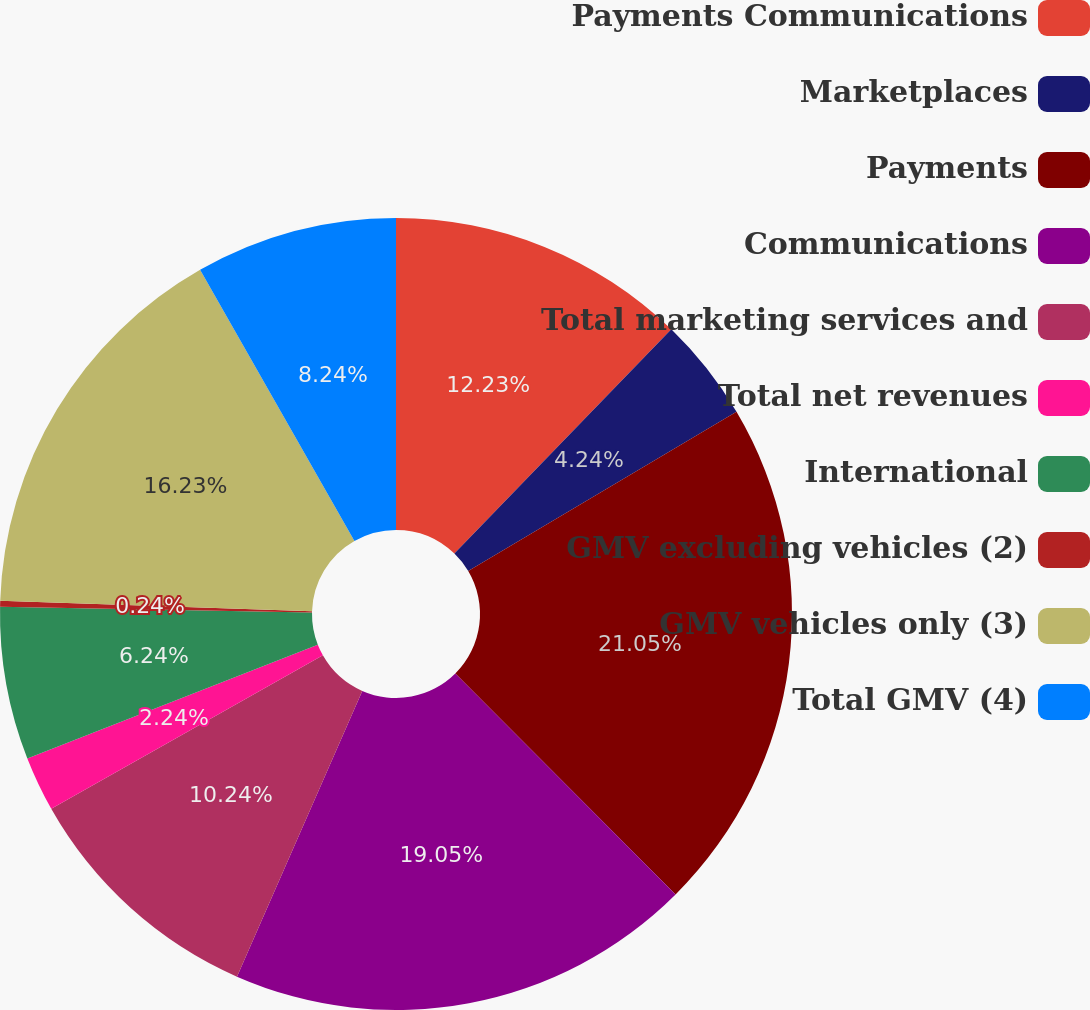<chart> <loc_0><loc_0><loc_500><loc_500><pie_chart><fcel>Payments Communications<fcel>Marketplaces<fcel>Payments<fcel>Communications<fcel>Total marketing services and<fcel>Total net revenues<fcel>International<fcel>GMV excluding vehicles (2)<fcel>GMV vehicles only (3)<fcel>Total GMV (4)<nl><fcel>12.24%<fcel>4.24%<fcel>21.06%<fcel>19.06%<fcel>10.24%<fcel>2.24%<fcel>6.24%<fcel>0.24%<fcel>16.24%<fcel>8.24%<nl></chart> 